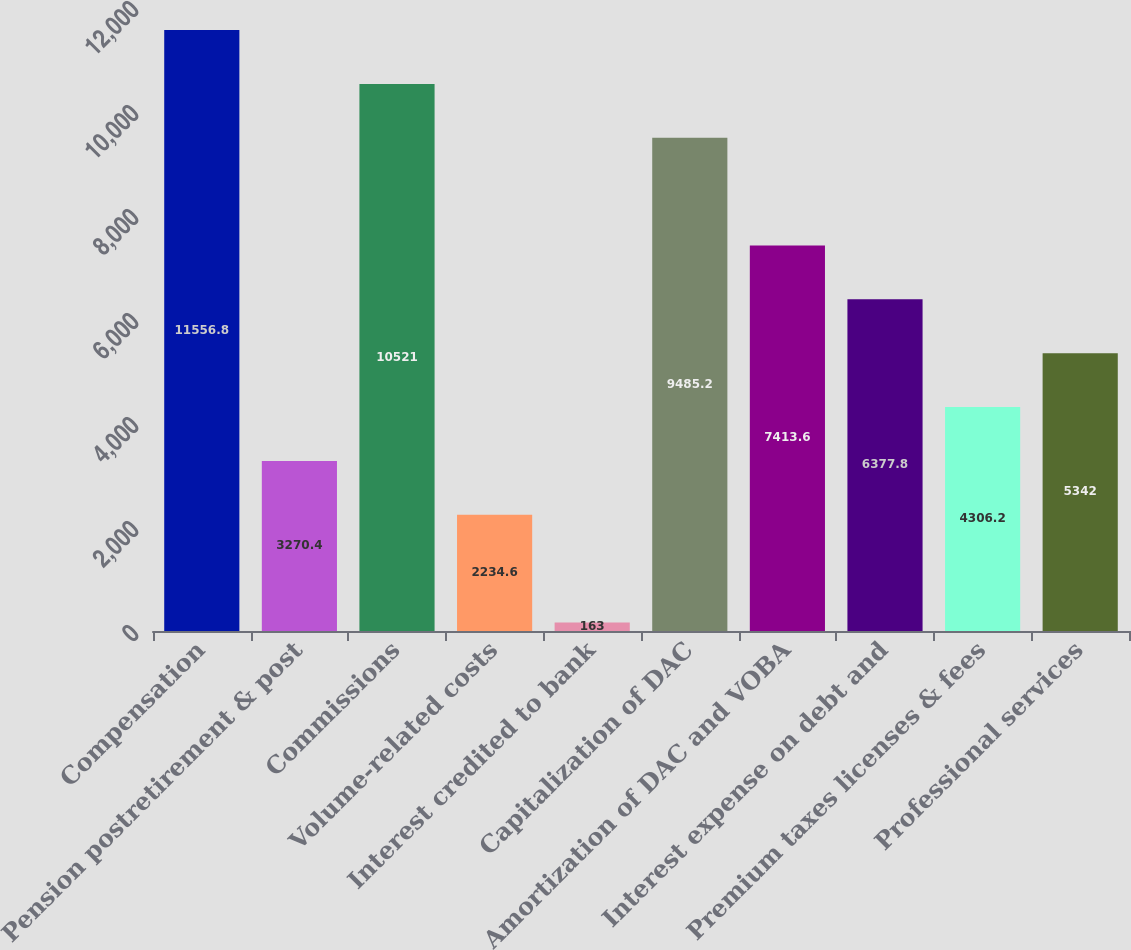<chart> <loc_0><loc_0><loc_500><loc_500><bar_chart><fcel>Compensation<fcel>Pension postretirement & post<fcel>Commissions<fcel>Volume-related costs<fcel>Interest credited to bank<fcel>Capitalization of DAC<fcel>Amortization of DAC and VOBA<fcel>Interest expense on debt and<fcel>Premium taxes licenses & fees<fcel>Professional services<nl><fcel>11556.8<fcel>3270.4<fcel>10521<fcel>2234.6<fcel>163<fcel>9485.2<fcel>7413.6<fcel>6377.8<fcel>4306.2<fcel>5342<nl></chart> 